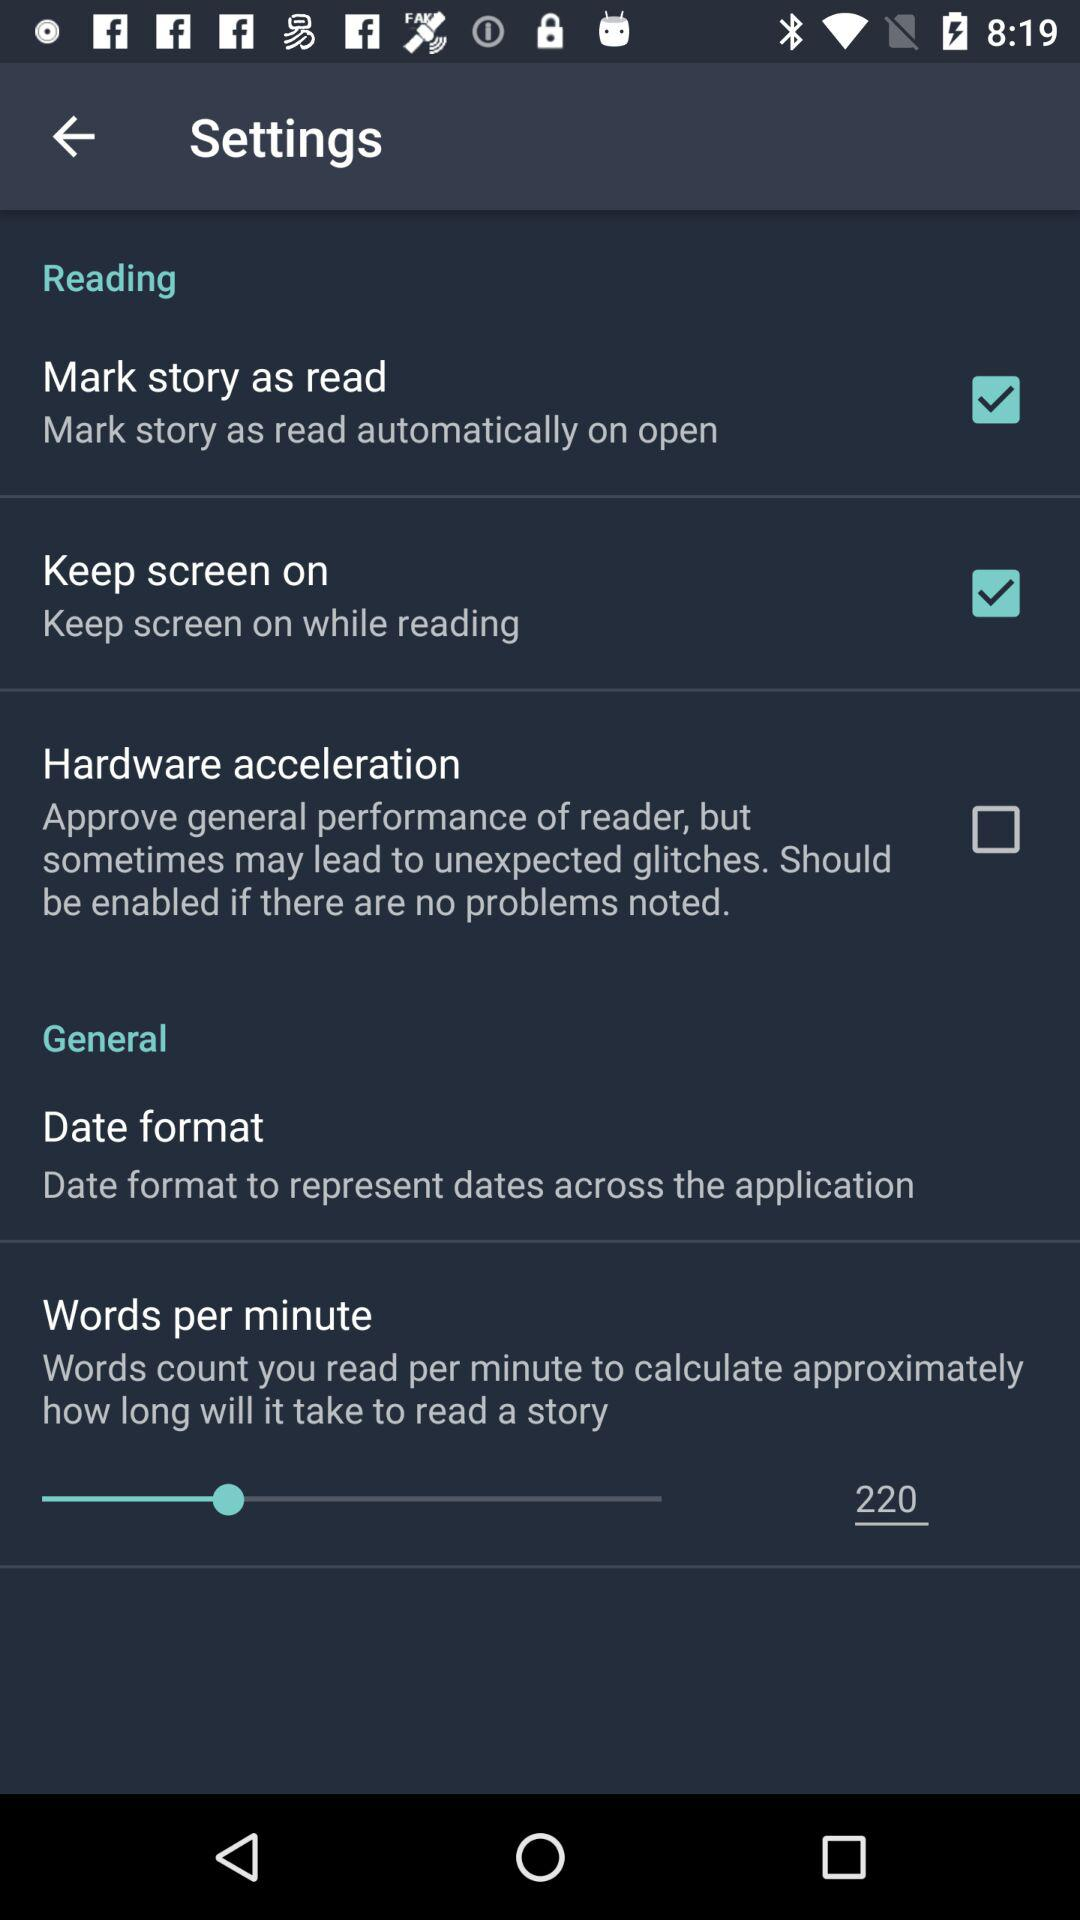What is the status of "Mark story as read"? The status is "on". 